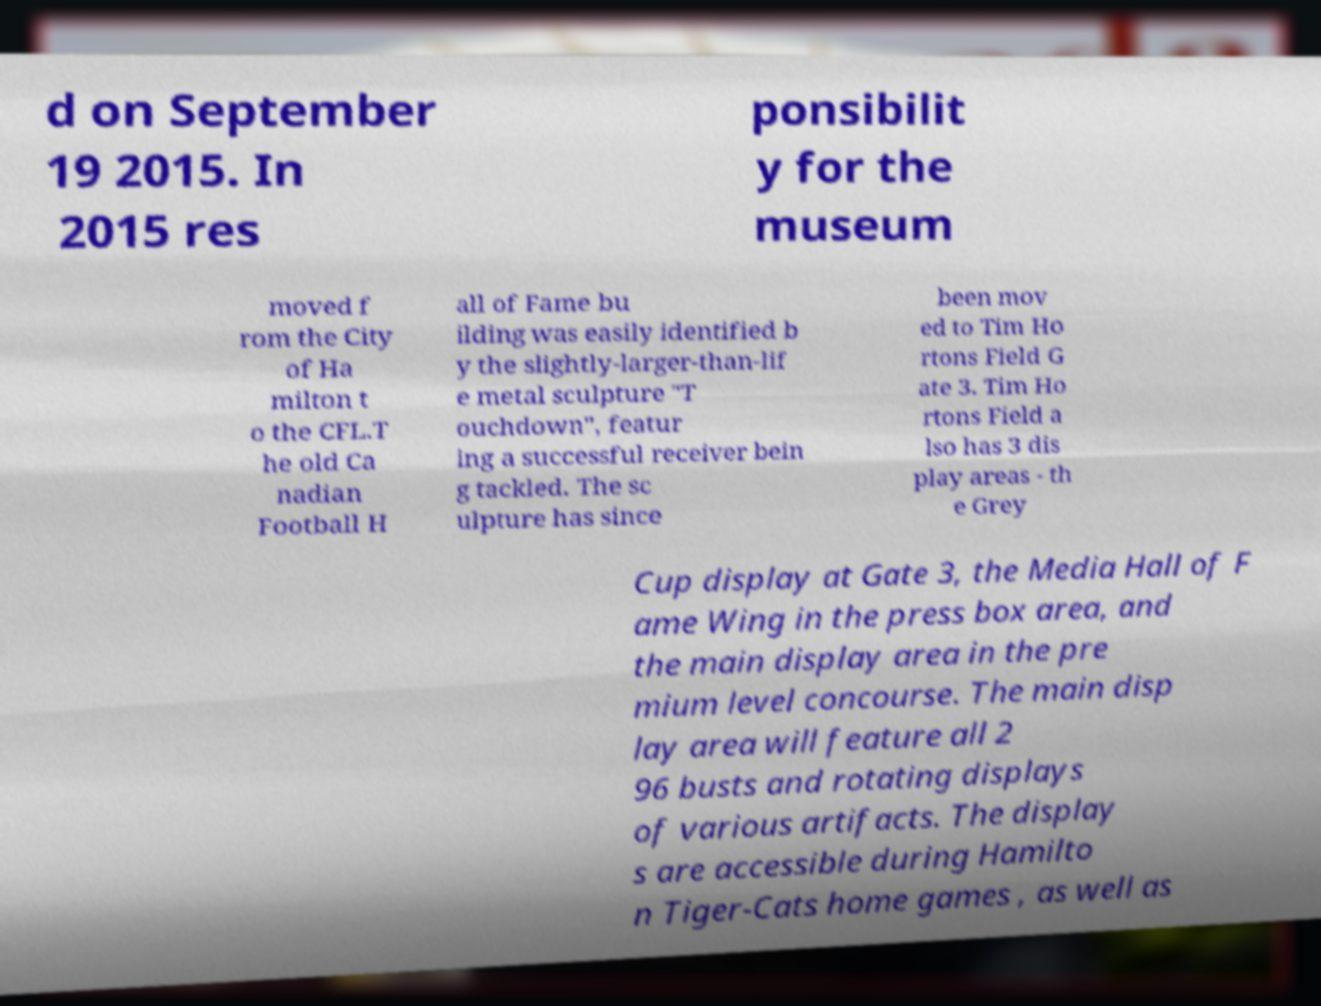Please identify and transcribe the text found in this image. d on September 19 2015. In 2015 res ponsibilit y for the museum moved f rom the City of Ha milton t o the CFL.T he old Ca nadian Football H all of Fame bu ilding was easily identified b y the slightly-larger-than-lif e metal sculpture "T ouchdown", featur ing a successful receiver bein g tackled. The sc ulpture has since been mov ed to Tim Ho rtons Field G ate 3. Tim Ho rtons Field a lso has 3 dis play areas - th e Grey Cup display at Gate 3, the Media Hall of F ame Wing in the press box area, and the main display area in the pre mium level concourse. The main disp lay area will feature all 2 96 busts and rotating displays of various artifacts. The display s are accessible during Hamilto n Tiger-Cats home games , as well as 